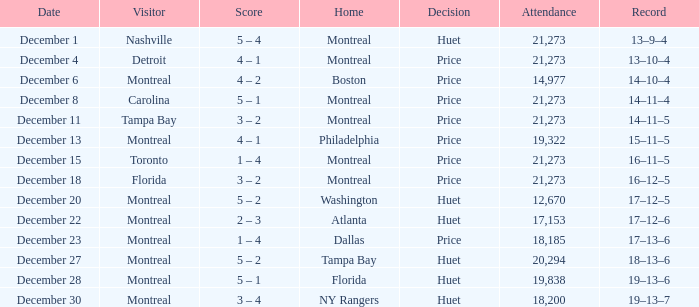Can you provide information on the significant record set on december 4? 13–10–4. 